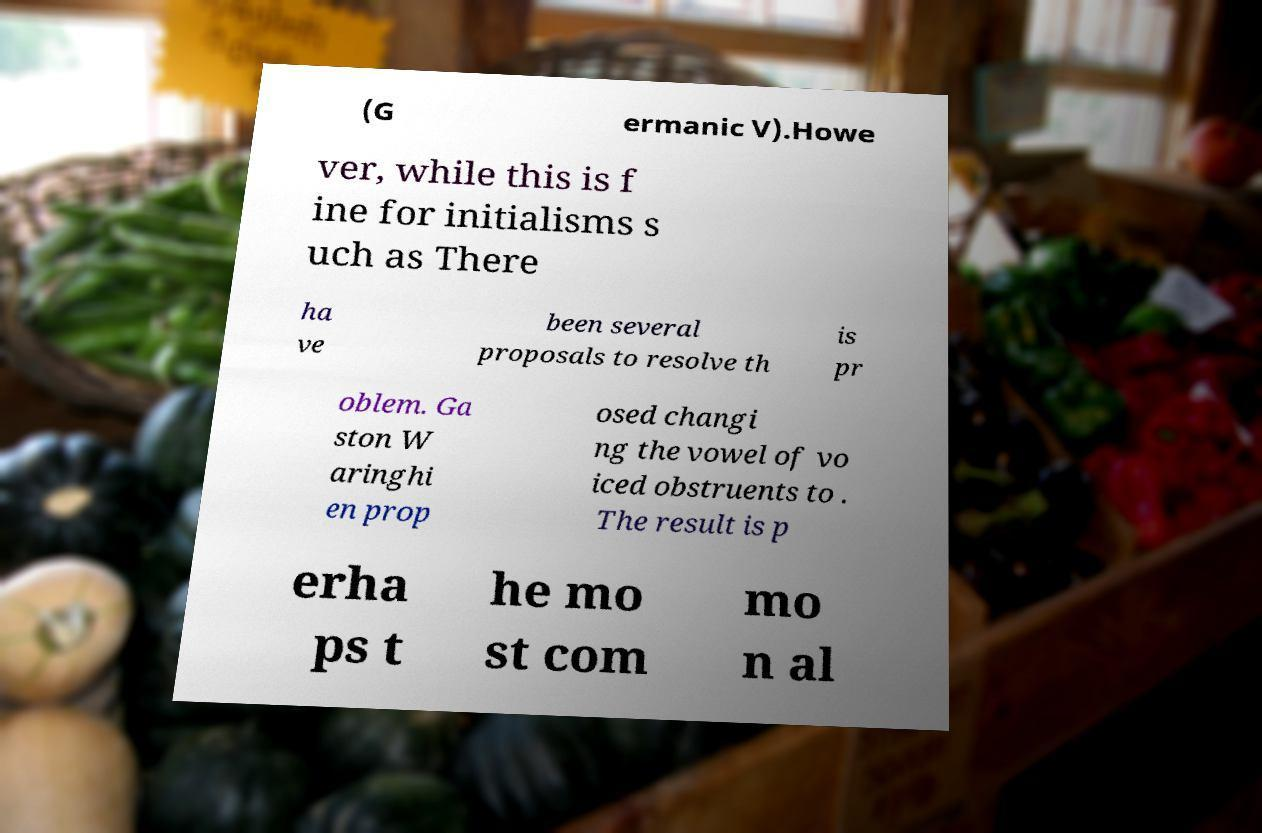For documentation purposes, I need the text within this image transcribed. Could you provide that? (G ermanic V).Howe ver, while this is f ine for initialisms s uch as There ha ve been several proposals to resolve th is pr oblem. Ga ston W aringhi en prop osed changi ng the vowel of vo iced obstruents to . The result is p erha ps t he mo st com mo n al 